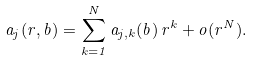<formula> <loc_0><loc_0><loc_500><loc_500>a _ { j } ( r , b ) = \sum _ { k = 1 } ^ { N } a _ { j , k } ( b ) \, r ^ { k } + o ( r ^ { N } ) .</formula> 